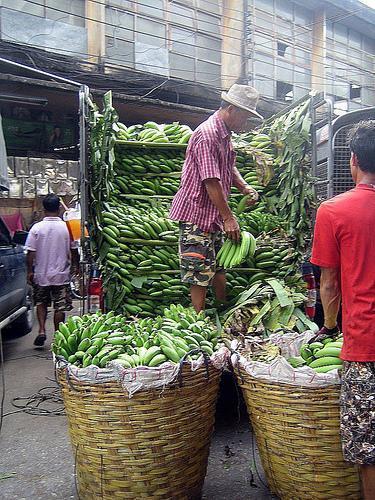How many baskets are in the photo?
Give a very brief answer. 2. How many people are visible?
Give a very brief answer. 3. How many cars are there?
Give a very brief answer. 1. How many bananas are in the photo?
Give a very brief answer. 2. 